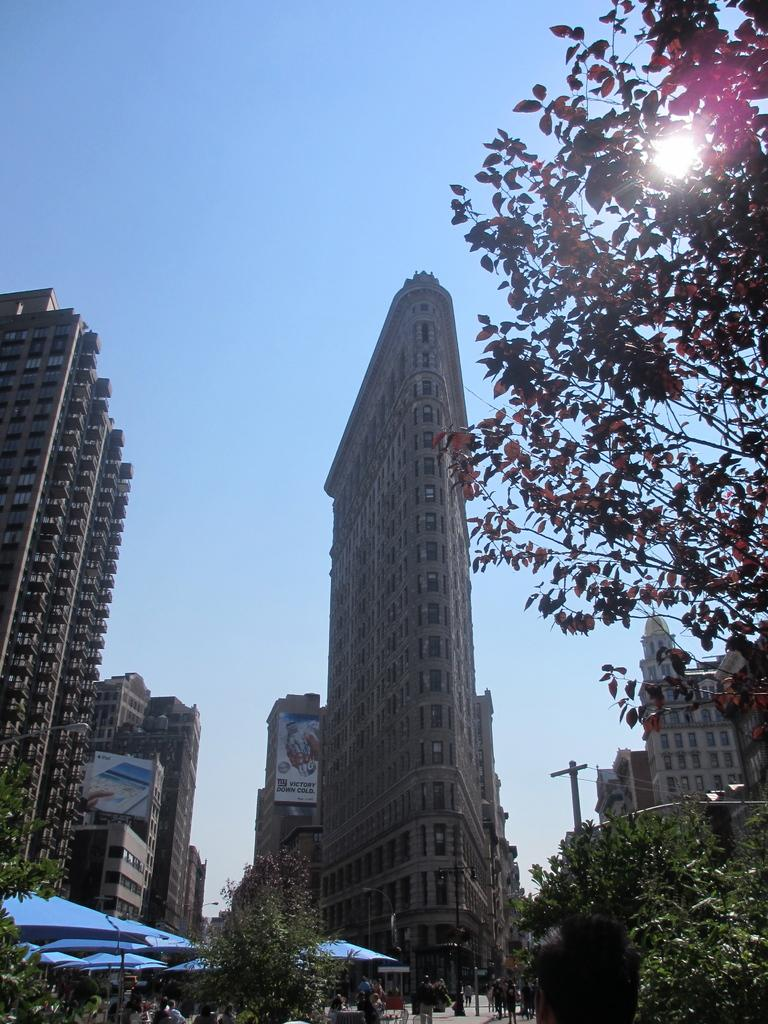What type of structures are present in the image? There are tall buildings in the image. What other natural elements can be seen in the image? There are trees in the image. What is visible in the background of the image? The sky is visible in the image. How many horses can be seen running through the mist in the image? There are no horses or mist present in the image. What type of engine is visible in the image? There is no engine present in the image. 